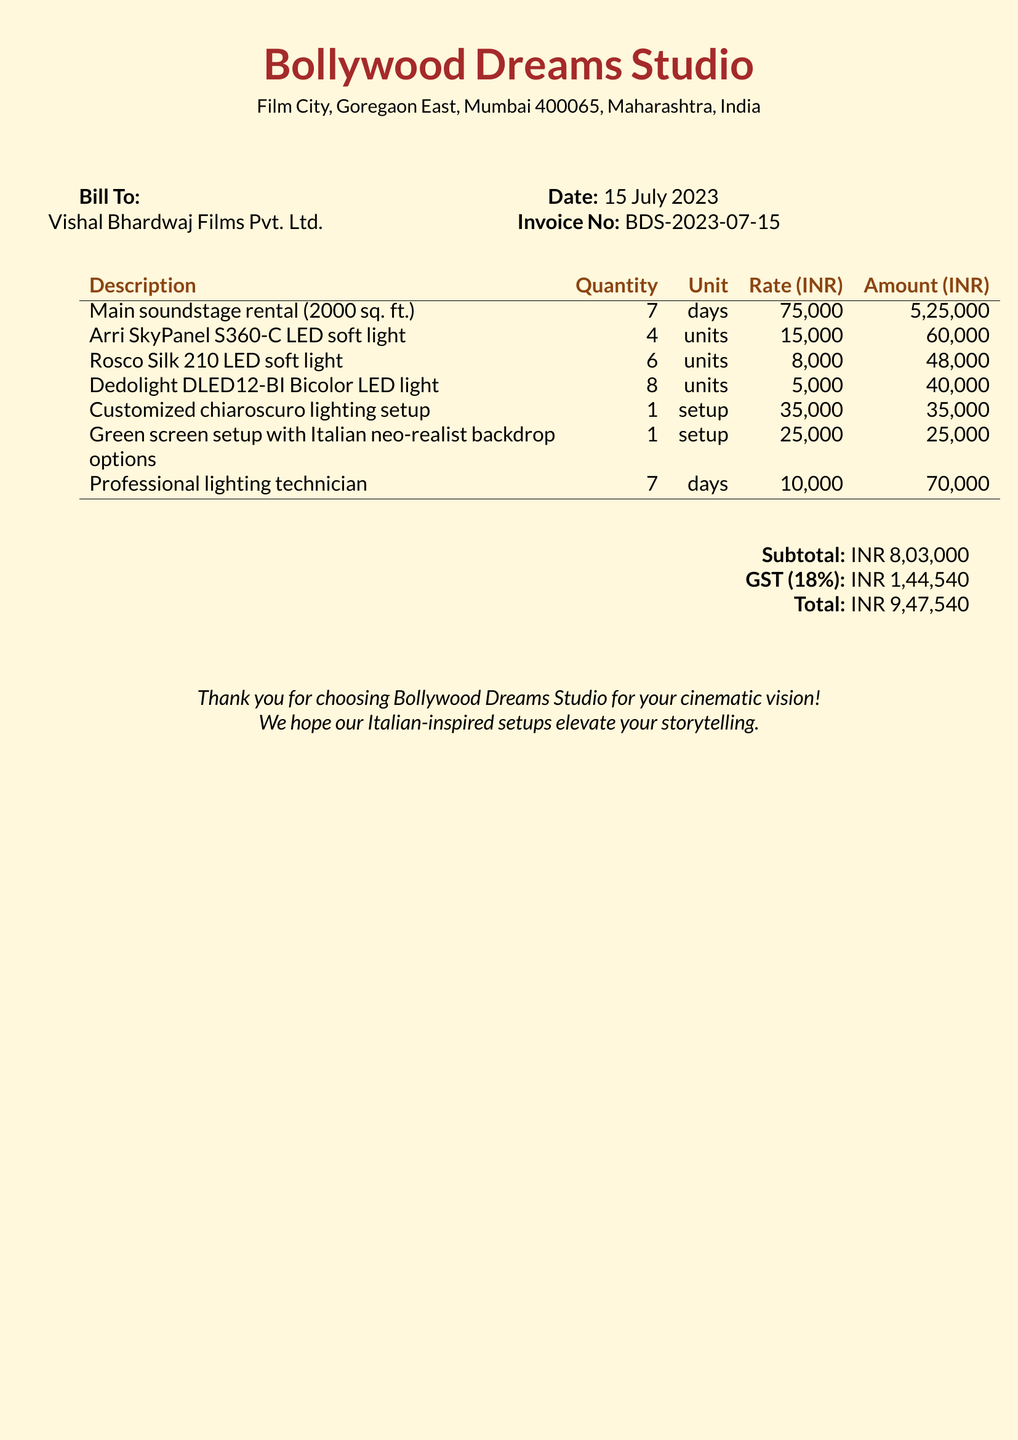What is the invoice number? The invoice number is provided in the document for reference, which is BDS-2023-07-15.
Answer: BDS-2023-07-15 What is the date of the bill? The date is indicated at the top of the document, which is 15 July 2023.
Answer: 15 July 2023 What is the total amount due? The total amount is the sum of the subtotal and the GST, which is listed at the bottom of the document.
Answer: INR 9,47,540 How many days was the main soundstage rented? The number of days for the main soundstage rental is specified in the description, which is 7 days.
Answer: 7 days What is the rate for the Arri SkyPanel S360-C LED soft light? The rate for this specific lighting unit is clearly mentioned in the document as 15,000.
Answer: 15,000 What is the subtotal amount? The subtotal amount is the total before GST, which is provided in the document.
Answer: INR 8,03,000 What lighting technician service duration is listed? The service for the professional lighting technician is provided for 7 days as specified in the document.
Answer: 7 days How much is charged for the customized chiaroscuro lighting setup? The amount charged for this setup is stated clearly in the document, which is 35,000.
Answer: 35,000 What type of backdrop options are included in the green screen setup? The document mentions the backdrop options being inspired by Italian neo-realism, indicating a specific style.
Answer: Italian neo-realist backdrop options 